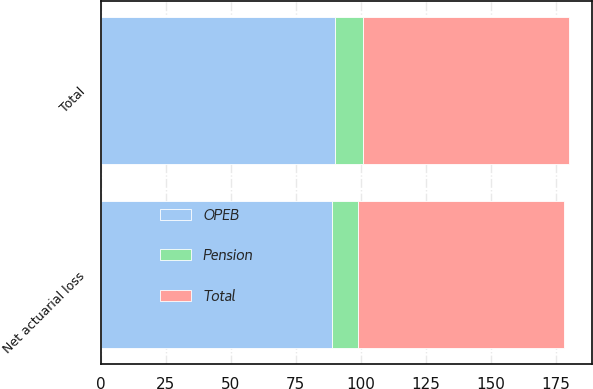Convert chart. <chart><loc_0><loc_0><loc_500><loc_500><stacked_bar_chart><ecel><fcel>Net actuarial loss<fcel>Total<nl><fcel>Total<fcel>79<fcel>79<nl><fcel>Pension<fcel>10<fcel>11<nl><fcel>OPEB<fcel>89<fcel>90<nl></chart> 